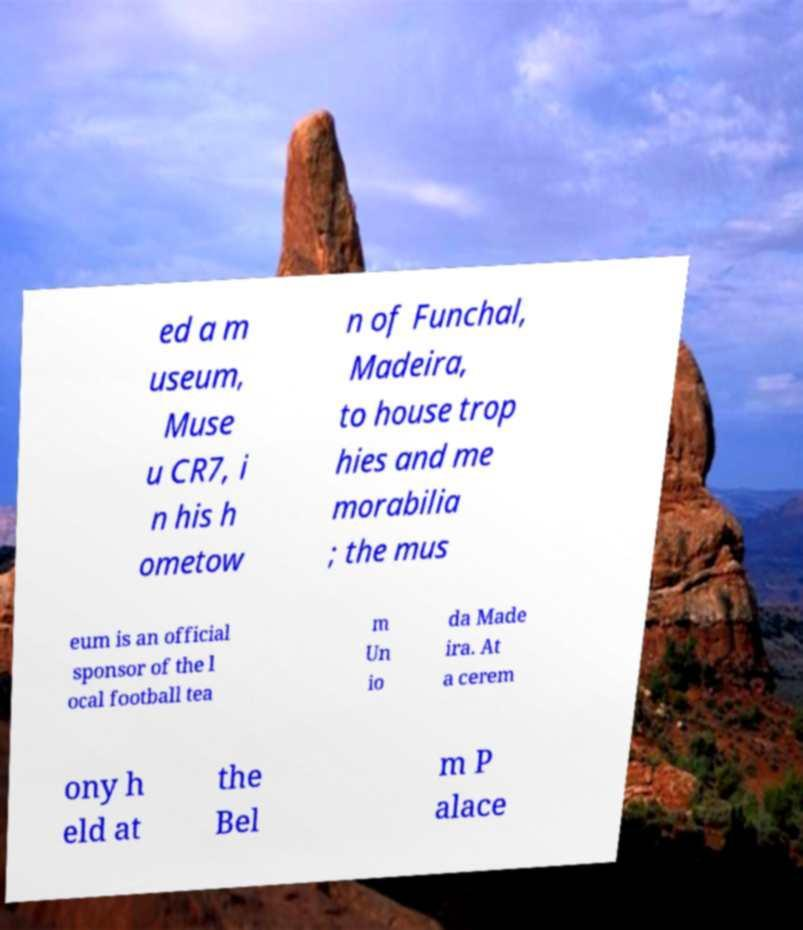Can you accurately transcribe the text from the provided image for me? ed a m useum, Muse u CR7, i n his h ometow n of Funchal, Madeira, to house trop hies and me morabilia ; the mus eum is an official sponsor of the l ocal football tea m Un io da Made ira. At a cerem ony h eld at the Bel m P alace 